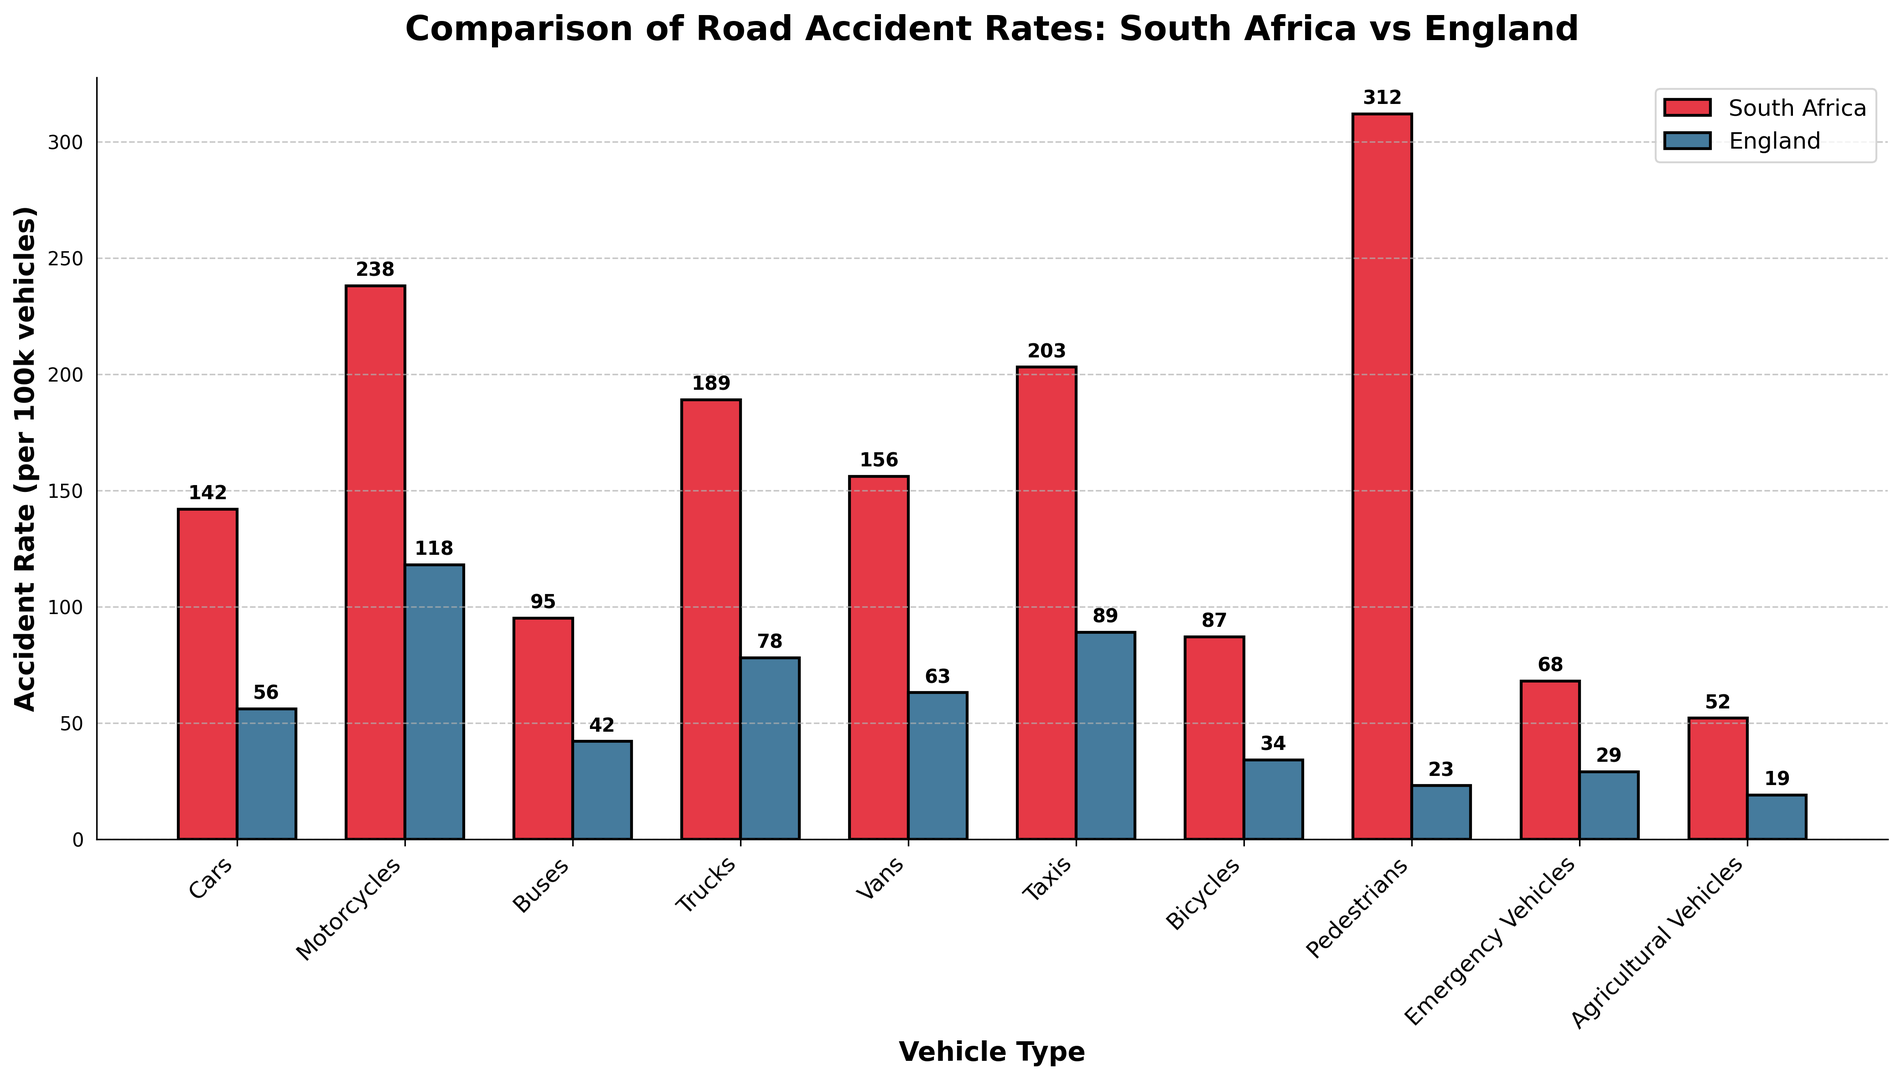Which vehicle type has the highest accident rate in South Africa? To determine the vehicle type with the highest accident rate in South Africa, we look at the bar representing each vehicle type. The bar for Pedestrians reaches the highest point.
Answer: Pedestrians Which vehicle type has the lowest accident rate in England? To find the vehicle type with the lowest accident rate in England, we compare the heights of the blue bars correspondingly. The bar for Agricultural Vehicles is the shortest.
Answer: Agricultural Vehicles How much higher is the motorcycle accident rate in South Africa compared to England? We subtract the accident rate for motorcycles in England from that in South Africa: 238 - 118 = 120.
Answer: 120 For which vehicle type is the difference in accident rates between South Africa and England the greatest? To find the greatest difference, we calculate the differences for each vehicle type and compare them. Pedestrians have the largest difference of 312 - 23 = 289.
Answer: Pedestrians Which country has a higher accident rate for vans, and by how much? Compare the heights of the bars representing van accident rates. The red bar (South Africa) is higher than the blue bar (England). The difference is 156 - 63 = 93.
Answer: South Africa by 93 What is the sum of accident rates for trucks and taxis in South Africa? Add the accident rates for trucks and taxis in South Africa: 189 + 203 = 392.
Answer: 392 Which vehicle type shows the smallest difference in accident rates between South Africa and England? We find the smallest difference by comparing the accident rates for each vehicle type. The difference for Buses is smallest at 95 - 42 = 53.
Answer: Buses Is the accident rate for bicycles higher in South Africa or England? Compare the heights of the bars for bicycles in both countries. The red bar (South Africa) is higher.
Answer: South Africa What is the average accident rate for emergency vehicles and agricultural vehicles in England? Calculate the average by summing the rates and dividing by the number of vehicle types: (29 + 19) / 2 = 24.
Answer: 24 How much lower is the accident rate for emergency vehicles compared to bicycles in South Africa? Subtract the rate for emergency vehicles from the rate for bicycles in South Africa: 87 - 68 = 19.
Answer: 19 